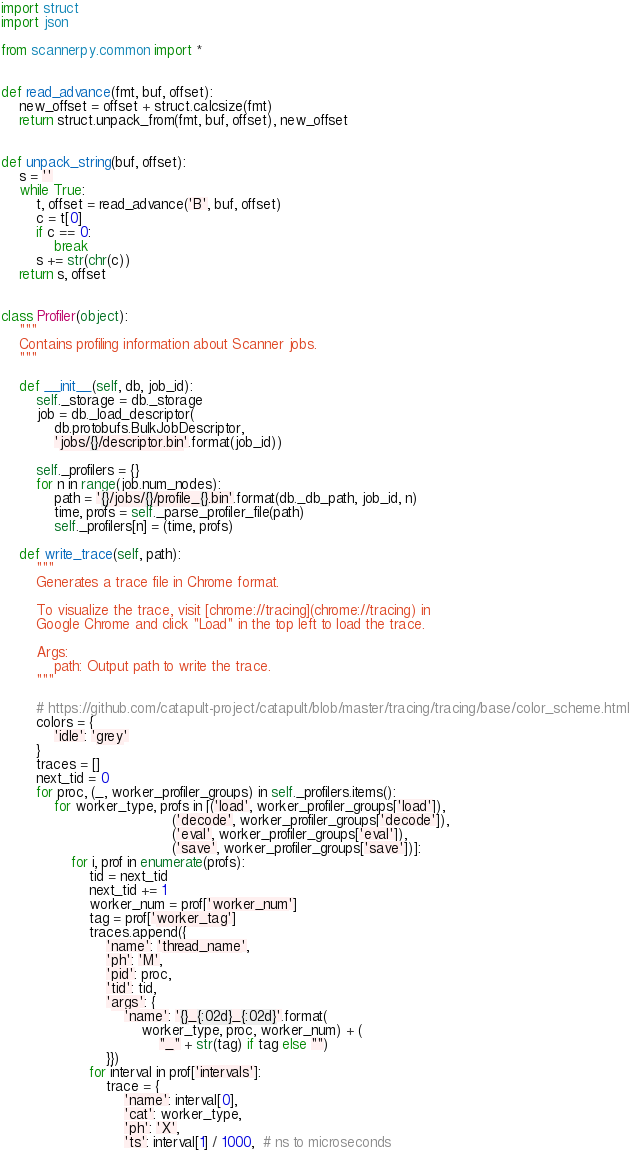Convert code to text. <code><loc_0><loc_0><loc_500><loc_500><_Python_>import struct
import json

from scannerpy.common import *


def read_advance(fmt, buf, offset):
    new_offset = offset + struct.calcsize(fmt)
    return struct.unpack_from(fmt, buf, offset), new_offset


def unpack_string(buf, offset):
    s = ''
    while True:
        t, offset = read_advance('B', buf, offset)
        c = t[0]
        if c == 0:
            break
        s += str(chr(c))
    return s, offset


class Profiler(object):
    """
    Contains profiling information about Scanner jobs.
    """

    def __init__(self, db, job_id):
        self._storage = db._storage
        job = db._load_descriptor(
            db.protobufs.BulkJobDescriptor,
            'jobs/{}/descriptor.bin'.format(job_id))

        self._profilers = {}
        for n in range(job.num_nodes):
            path = '{}/jobs/{}/profile_{}.bin'.format(db._db_path, job_id, n)
            time, profs = self._parse_profiler_file(path)
            self._profilers[n] = (time, profs)

    def write_trace(self, path):
        """
        Generates a trace file in Chrome format.

        To visualize the trace, visit [chrome://tracing](chrome://tracing) in
        Google Chrome and click "Load" in the top left to load the trace.

        Args:
            path: Output path to write the trace.
        """

        # https://github.com/catapult-project/catapult/blob/master/tracing/tracing/base/color_scheme.html
        colors = {
            'idle': 'grey'
        }
        traces = []
        next_tid = 0
        for proc, (_, worker_profiler_groups) in self._profilers.items():
            for worker_type, profs in [('load', worker_profiler_groups['load']),
                                       ('decode', worker_profiler_groups['decode']),
                                       ('eval', worker_profiler_groups['eval']),
                                       ('save', worker_profiler_groups['save'])]:
                for i, prof in enumerate(profs):
                    tid = next_tid
                    next_tid += 1
                    worker_num = prof['worker_num']
                    tag = prof['worker_tag']
                    traces.append({
                        'name': 'thread_name',
                        'ph': 'M',
                        'pid': proc,
                        'tid': tid,
                        'args': {
                            'name': '{}_{:02d}_{:02d}'.format(
                                worker_type, proc, worker_num) + (
                                    "_" + str(tag) if tag else "")
                        }})
                    for interval in prof['intervals']:
                        trace = {
                            'name': interval[0],
                            'cat': worker_type,
                            'ph': 'X',
                            'ts': interval[1] / 1000,  # ns to microseconds</code> 